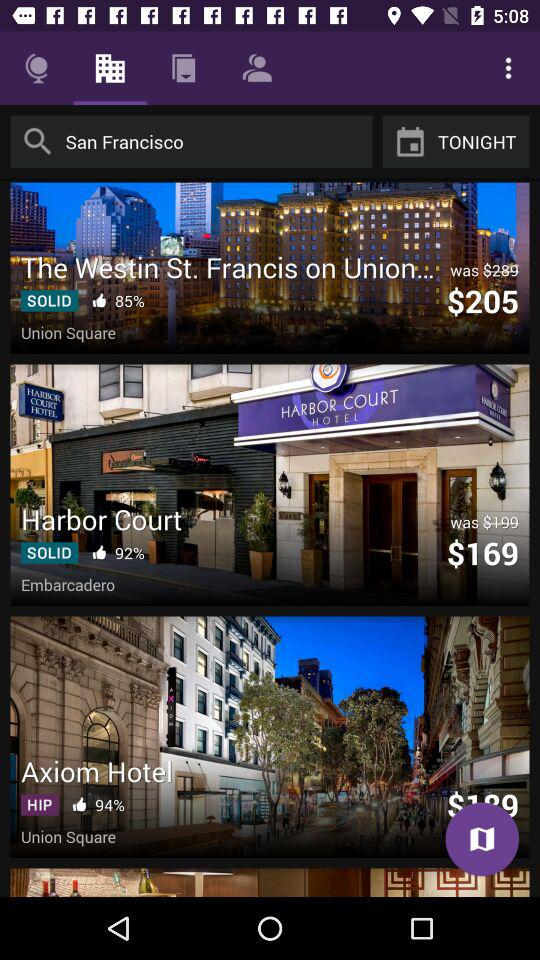How many hotels are displayed on the screen? 3 